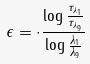<formula> <loc_0><loc_0><loc_500><loc_500>\epsilon = \cdot \frac { \log \frac { \tau _ { \lambda _ { 1 } } } { \tau _ { \lambda _ { 9 } } } } { \log \frac { \lambda _ { 1 } } { \lambda _ { 9 } } }</formula> 